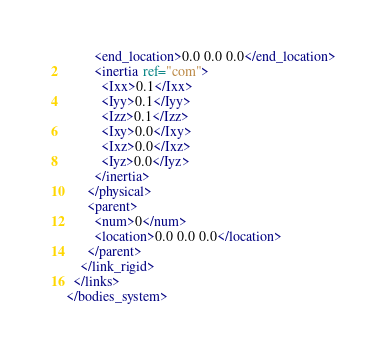Convert code to text. <code><loc_0><loc_0><loc_500><loc_500><_XML_>        <end_location>0.0 0.0 0.0</end_location>
        <inertia ref="com">
          <Ixx>0.1</Ixx>
          <Iyy>0.1</Iyy>
          <Izz>0.1</Izz>
          <Ixy>0.0</Ixy>
          <Ixz>0.0</Ixz>
          <Iyz>0.0</Iyz>
        </inertia>
      </physical>
      <parent>
        <num>0</num>
        <location>0.0 0.0 0.0</location>
      </parent>
    </link_rigid>
  </links>
</bodies_system></code> 